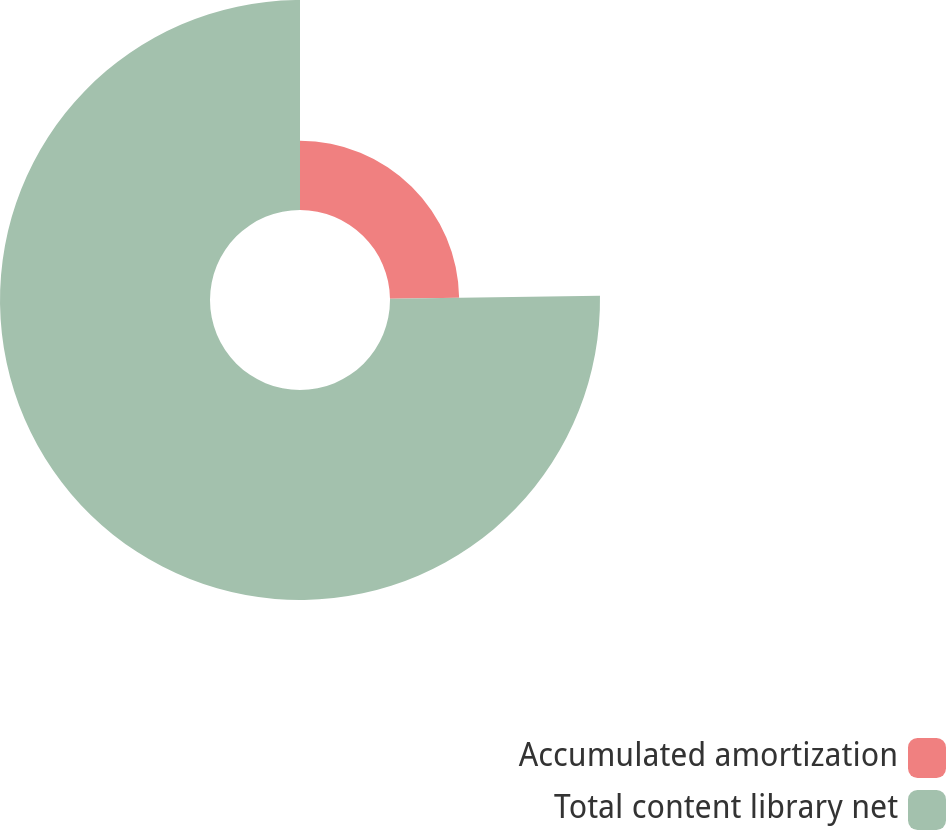Convert chart to OTSL. <chart><loc_0><loc_0><loc_500><loc_500><pie_chart><fcel>Accumulated amortization<fcel>Total content library net<nl><fcel>24.77%<fcel>75.23%<nl></chart> 